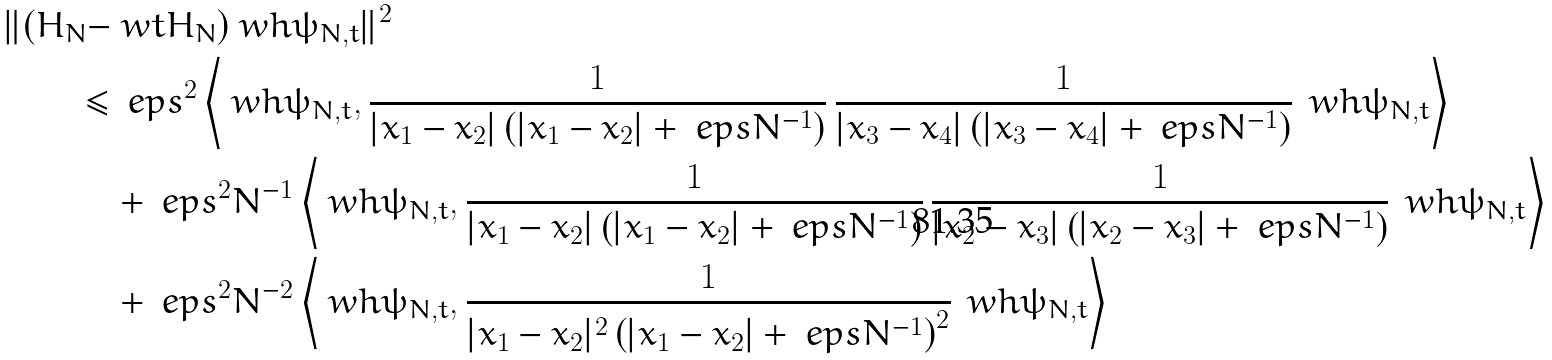<formula> <loc_0><loc_0><loc_500><loc_500>\| ( H _ { N } - & \ w t H _ { N } ) \ w h \psi _ { N , t } \| ^ { 2 } \\ \leq & \, \ e p s ^ { 2 } \left \langle \ w h \psi _ { N , t } , \frac { 1 } { | x _ { 1 } - x _ { 2 } | \left ( | x _ { 1 } - x _ { 2 } | + \ e p s N ^ { - 1 } \right ) } \, \frac { 1 } { | x _ { 3 } - x _ { 4 } | \left ( | x _ { 3 } - x _ { 4 } | + \ e p s N ^ { - 1 } \right ) } \, \ w h \psi _ { N , t } \right \rangle \\ & + \ e p s ^ { 2 } N ^ { - 1 } \left \langle \ w h \psi _ { N , t } , \frac { 1 } { | x _ { 1 } - x _ { 2 } | \left ( | x _ { 1 } - x _ { 2 } | + \ e p s N ^ { - 1 } \right ) } \, \frac { 1 } { | x _ { 2 } - x _ { 3 } | \left ( | x _ { 2 } - x _ { 3 } | + \ e p s N ^ { - 1 } \right ) } \, \ w h \psi _ { N , t } \right \rangle \\ & + \ e p s ^ { 2 } N ^ { - 2 } \left \langle \ w h \psi _ { N , t } , \frac { 1 } { | x _ { 1 } - x _ { 2 } | ^ { 2 } \left ( | x _ { 1 } - x _ { 2 } | + \ e p s N ^ { - 1 } \right ) ^ { 2 } } \, \ w h \psi _ { N , t } \right \rangle</formula> 